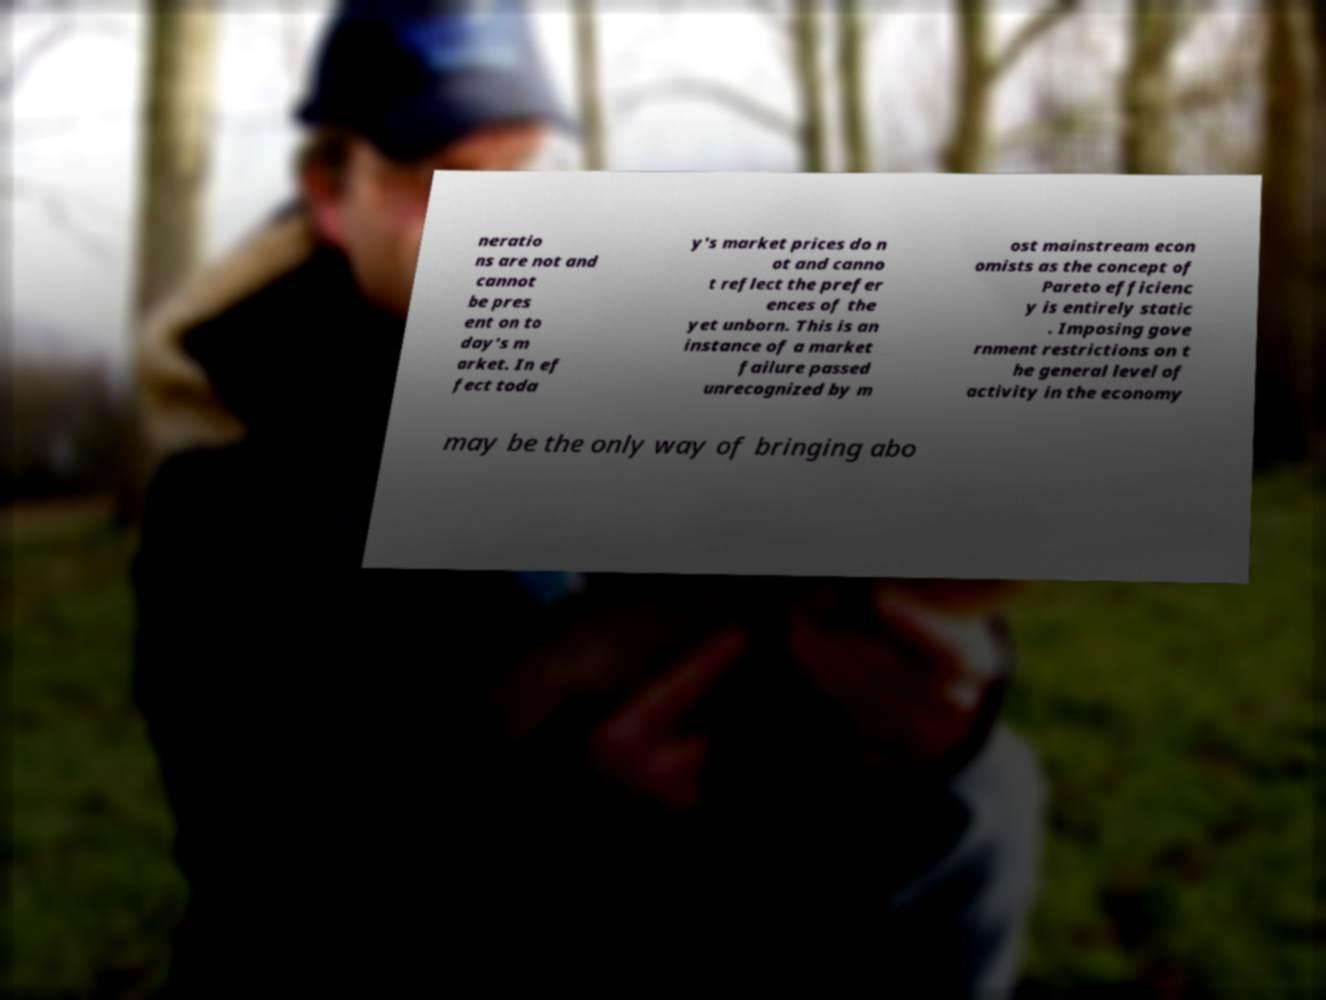Could you assist in decoding the text presented in this image and type it out clearly? neratio ns are not and cannot be pres ent on to day's m arket. In ef fect toda y's market prices do n ot and canno t reflect the prefer ences of the yet unborn. This is an instance of a market failure passed unrecognized by m ost mainstream econ omists as the concept of Pareto efficienc y is entirely static . Imposing gove rnment restrictions on t he general level of activity in the economy may be the only way of bringing abo 